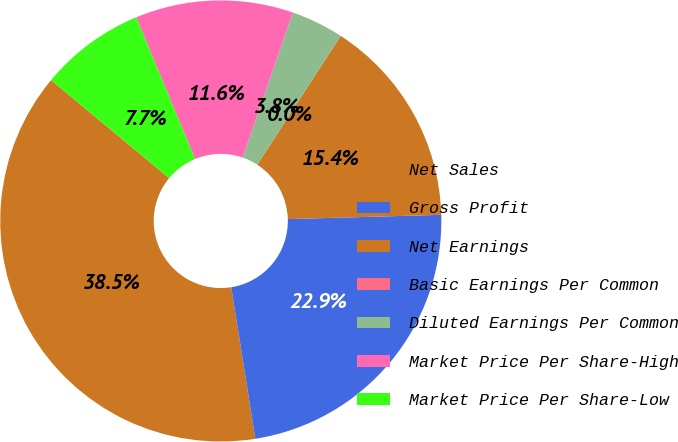Convert chart. <chart><loc_0><loc_0><loc_500><loc_500><pie_chart><fcel>Net Sales<fcel>Gross Profit<fcel>Net Earnings<fcel>Basic Earnings Per Common<fcel>Diluted Earnings Per Common<fcel>Market Price Per Share-High<fcel>Market Price Per Share-Low<nl><fcel>38.53%<fcel>22.94%<fcel>15.41%<fcel>0.0%<fcel>3.85%<fcel>11.56%<fcel>7.71%<nl></chart> 